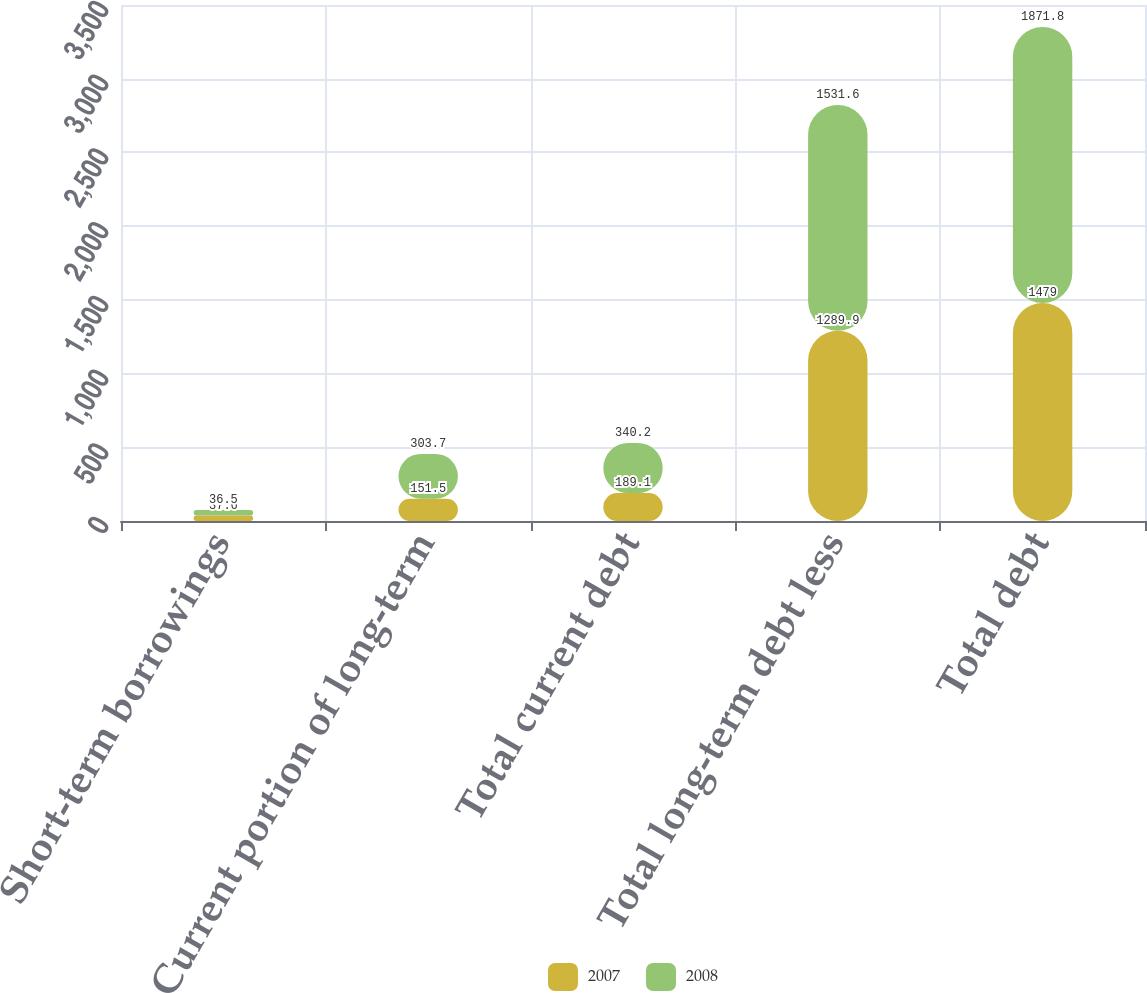Convert chart. <chart><loc_0><loc_0><loc_500><loc_500><stacked_bar_chart><ecel><fcel>Short-term borrowings<fcel>Current portion of long-term<fcel>Total current debt<fcel>Total long-term debt less<fcel>Total debt<nl><fcel>2007<fcel>37.6<fcel>151.5<fcel>189.1<fcel>1289.9<fcel>1479<nl><fcel>2008<fcel>36.5<fcel>303.7<fcel>340.2<fcel>1531.6<fcel>1871.8<nl></chart> 